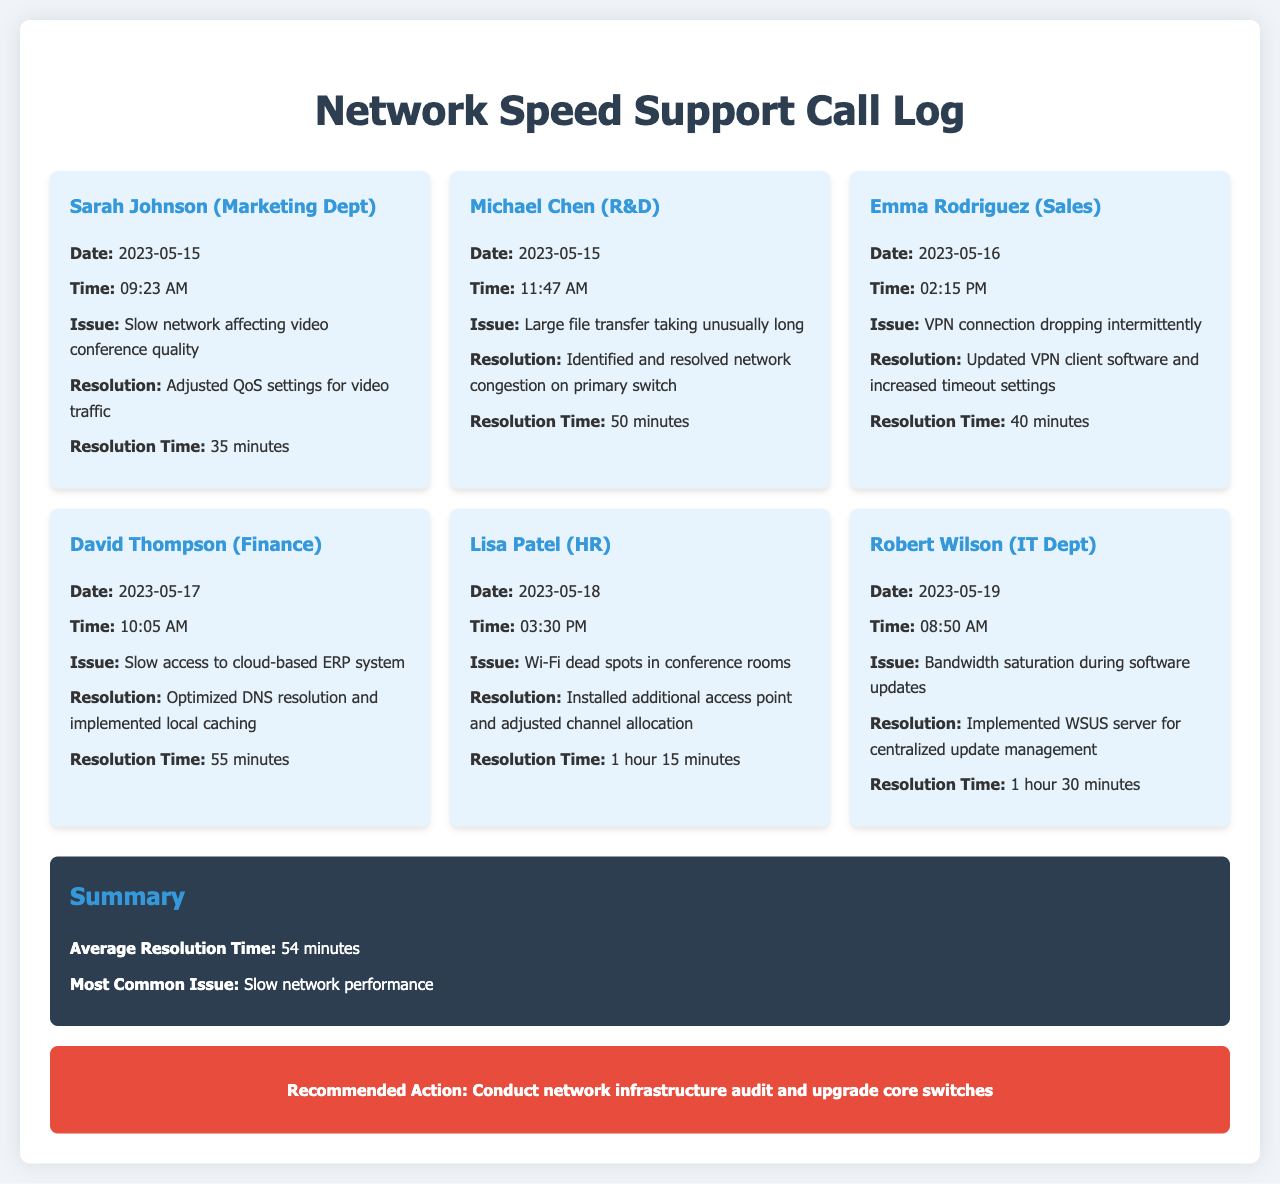What issue did Sarah Johnson report? Sarah Johnson reported that the slow network was affecting video conference quality.
Answer: Slow network affecting video conference quality What was the resolution time for Robert Wilson's issue? Robert Wilson's issue was resolved in 1 hour 30 minutes.
Answer: 1 hour 30 minutes Who experienced slow access to the cloud-based ERP system? David Thompson from the Finance department experienced this issue.
Answer: David Thompson (Finance) What was the most common issue reported in the document? The summary states that the most common issue was slow network performance.
Answer: Slow network performance How many minutes did it take to resolve Emma Rodriguez's issue? Emma Rodriguez's issue was resolved in 40 minutes, as stated in the call log.
Answer: 40 minutes What action is recommended based on the summary? The recommended action is to conduct a network infrastructure audit and upgrade core switches.
Answer: Conduct network infrastructure audit and upgrade core switches Which department reported a problem with VPN connection? The Sales department reported a problem with VPN connection, as identified by Emma Rodriguez.
Answer: Sales On what date did Lisa Patel report her issue? Lisa Patel reported her issue on May 18, 2023, according to the call log.
Answer: 2023-05-18 